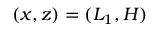<formula> <loc_0><loc_0><loc_500><loc_500>( x , z ) = ( L _ { 1 } , H )</formula> 